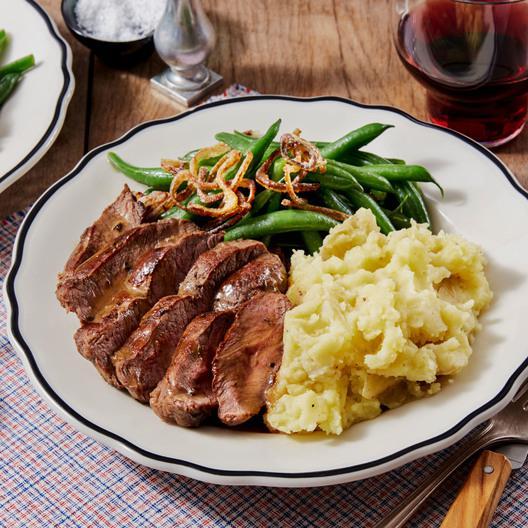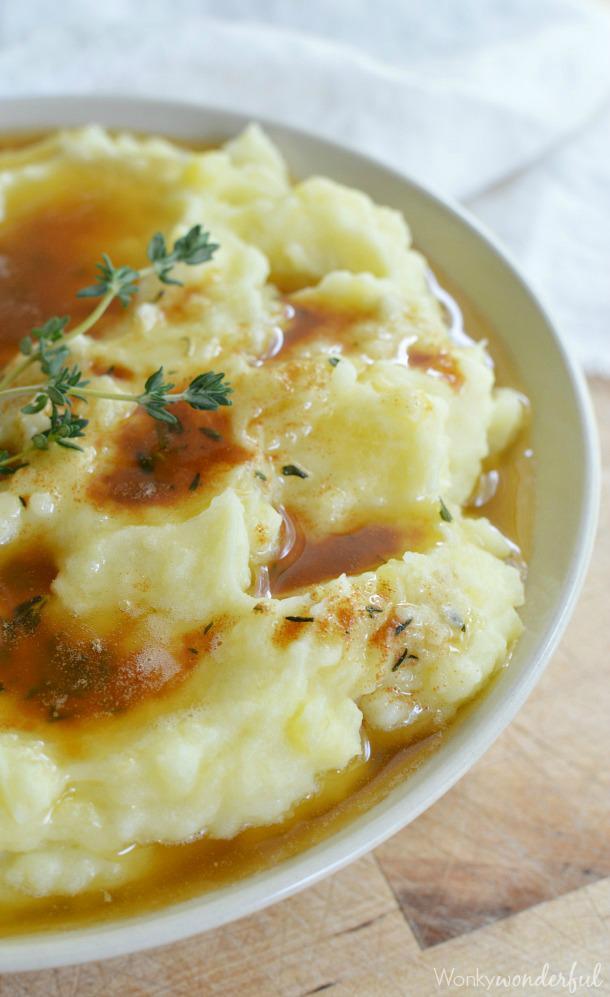The first image is the image on the left, the second image is the image on the right. Given the left and right images, does the statement "Each image shows mashed potatoes on a round white dish, at least one image shows brown broth over the potatoes, and a piece of silverware is to the right of one dish." hold true? Answer yes or no. Yes. The first image is the image on the left, the second image is the image on the right. For the images displayed, is the sentence "In one image, brown gravy and a spring of chive are on mashed potatoes in a white bowl." factually correct? Answer yes or no. Yes. 